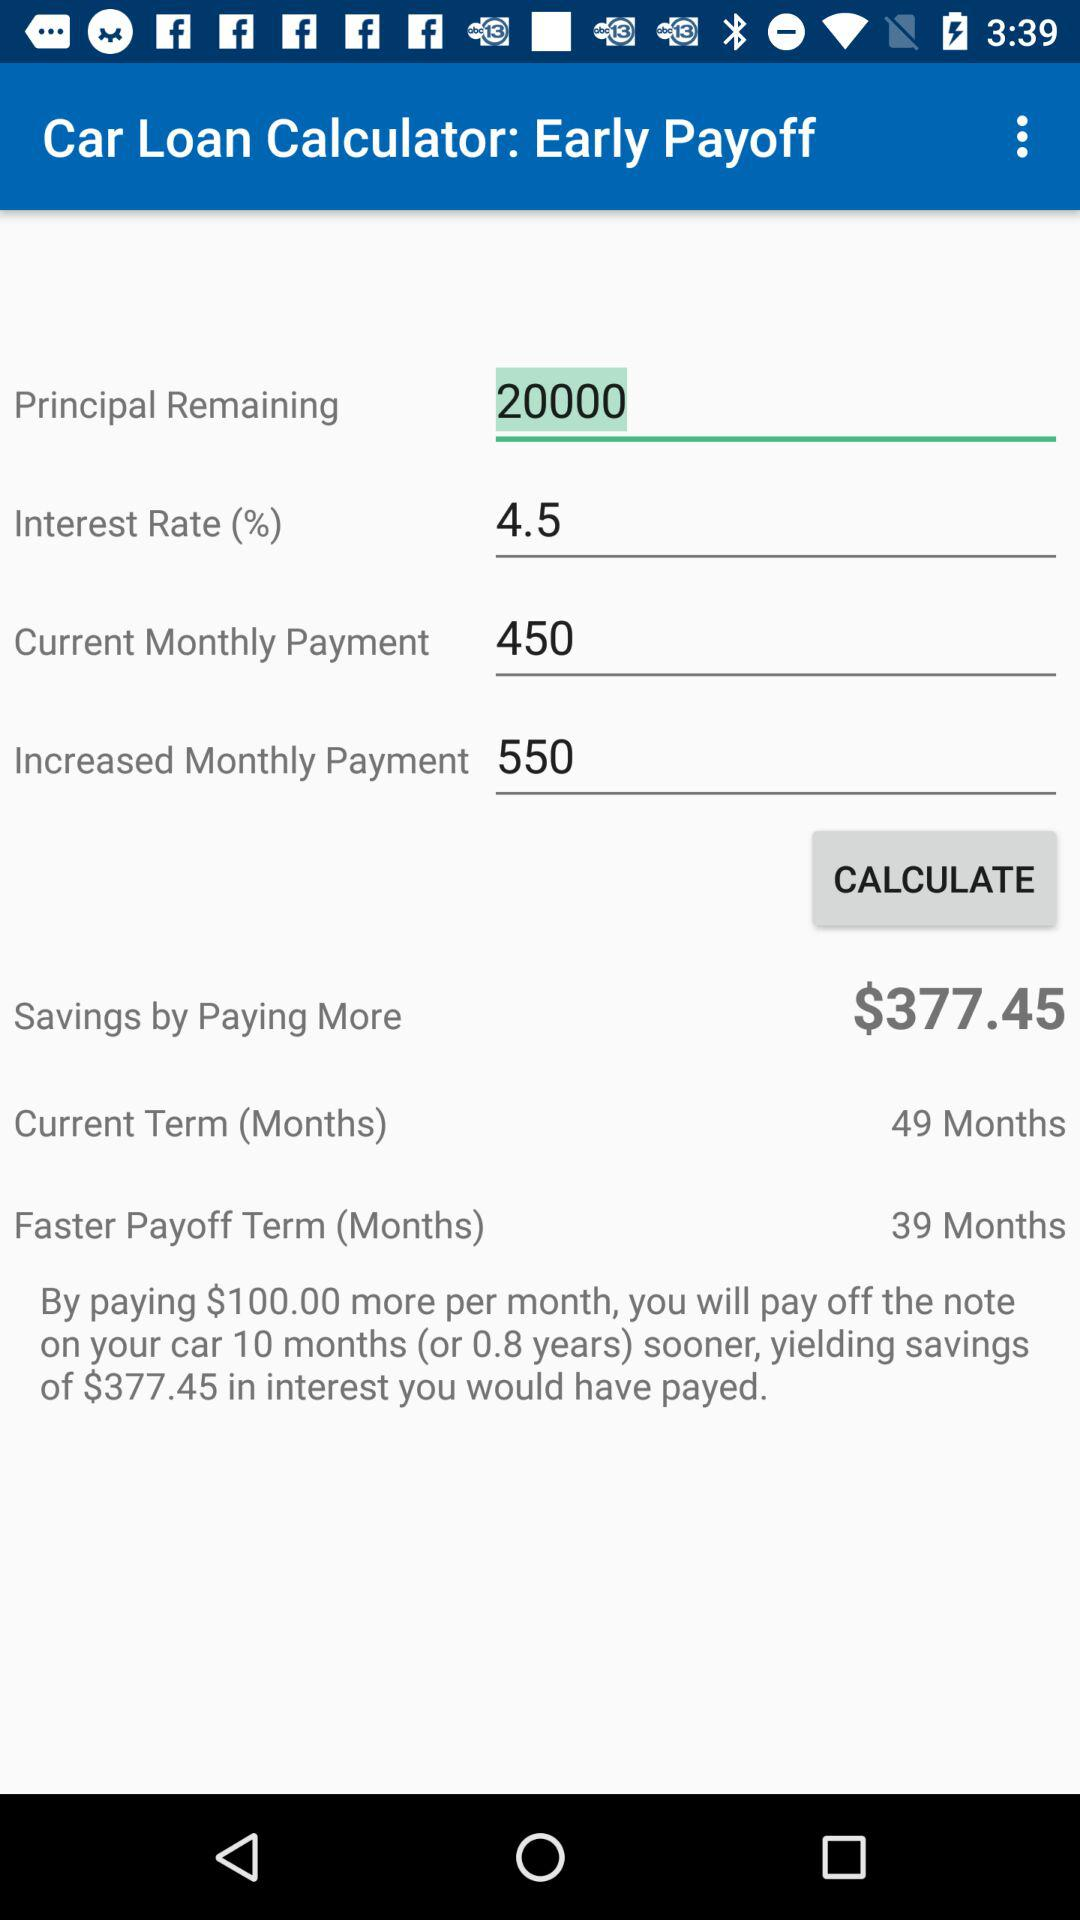How many months will I pay off my car loan early by paying $100 more per month?
Answer the question using a single word or phrase. 10 months 